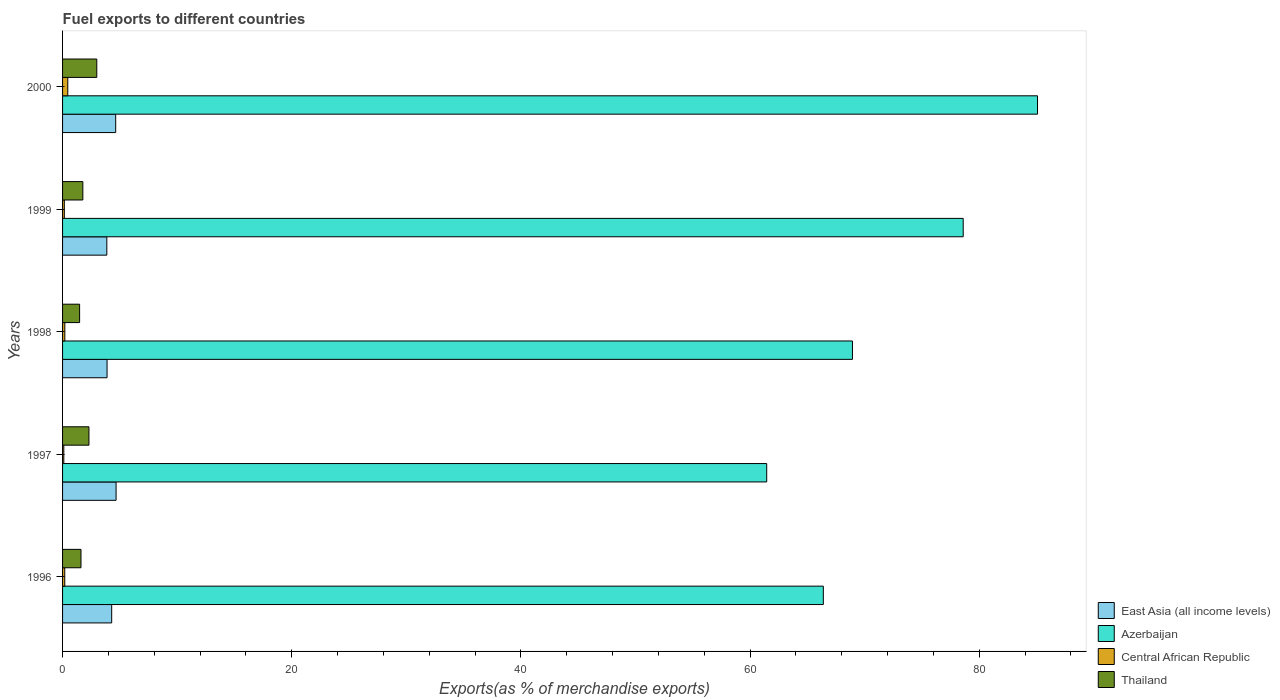Are the number of bars per tick equal to the number of legend labels?
Keep it short and to the point. Yes. How many bars are there on the 4th tick from the top?
Give a very brief answer. 4. How many bars are there on the 4th tick from the bottom?
Your answer should be very brief. 4. In how many cases, is the number of bars for a given year not equal to the number of legend labels?
Provide a short and direct response. 0. What is the percentage of exports to different countries in Azerbaijan in 1996?
Provide a succinct answer. 66.39. Across all years, what is the maximum percentage of exports to different countries in Azerbaijan?
Your answer should be compact. 85.08. Across all years, what is the minimum percentage of exports to different countries in Thailand?
Make the answer very short. 1.49. What is the total percentage of exports to different countries in Central African Republic in the graph?
Offer a very short reply. 1.1. What is the difference between the percentage of exports to different countries in Central African Republic in 1998 and that in 1999?
Provide a short and direct response. 0.04. What is the difference between the percentage of exports to different countries in Central African Republic in 2000 and the percentage of exports to different countries in Thailand in 1997?
Make the answer very short. -1.85. What is the average percentage of exports to different countries in Azerbaijan per year?
Offer a very short reply. 72.09. In the year 1998, what is the difference between the percentage of exports to different countries in Central African Republic and percentage of exports to different countries in Thailand?
Your answer should be compact. -1.29. In how many years, is the percentage of exports to different countries in Azerbaijan greater than 32 %?
Give a very brief answer. 5. What is the ratio of the percentage of exports to different countries in Central African Republic in 1996 to that in 2000?
Provide a succinct answer. 0.42. Is the percentage of exports to different countries in East Asia (all income levels) in 1996 less than that in 1998?
Make the answer very short. No. What is the difference between the highest and the second highest percentage of exports to different countries in Thailand?
Make the answer very short. 0.69. What is the difference between the highest and the lowest percentage of exports to different countries in East Asia (all income levels)?
Provide a short and direct response. 0.81. In how many years, is the percentage of exports to different countries in Thailand greater than the average percentage of exports to different countries in Thailand taken over all years?
Ensure brevity in your answer.  2. What does the 4th bar from the top in 1999 represents?
Make the answer very short. East Asia (all income levels). What does the 1st bar from the bottom in 1999 represents?
Offer a terse response. East Asia (all income levels). Is it the case that in every year, the sum of the percentage of exports to different countries in East Asia (all income levels) and percentage of exports to different countries in Azerbaijan is greater than the percentage of exports to different countries in Thailand?
Offer a terse response. Yes. How many bars are there?
Your response must be concise. 20. How many years are there in the graph?
Give a very brief answer. 5. What is the difference between two consecutive major ticks on the X-axis?
Offer a terse response. 20. Are the values on the major ticks of X-axis written in scientific E-notation?
Make the answer very short. No. Does the graph contain any zero values?
Ensure brevity in your answer.  No. Does the graph contain grids?
Provide a short and direct response. No. How many legend labels are there?
Make the answer very short. 4. What is the title of the graph?
Give a very brief answer. Fuel exports to different countries. What is the label or title of the X-axis?
Offer a very short reply. Exports(as % of merchandise exports). What is the Exports(as % of merchandise exports) in East Asia (all income levels) in 1996?
Give a very brief answer. 4.29. What is the Exports(as % of merchandise exports) of Azerbaijan in 1996?
Offer a terse response. 66.39. What is the Exports(as % of merchandise exports) of Central African Republic in 1996?
Provide a succinct answer. 0.19. What is the Exports(as % of merchandise exports) of Thailand in 1996?
Offer a very short reply. 1.61. What is the Exports(as % of merchandise exports) in East Asia (all income levels) in 1997?
Ensure brevity in your answer.  4.67. What is the Exports(as % of merchandise exports) in Azerbaijan in 1997?
Your response must be concise. 61.45. What is the Exports(as % of merchandise exports) of Central African Republic in 1997?
Offer a very short reply. 0.11. What is the Exports(as % of merchandise exports) in Thailand in 1997?
Your answer should be compact. 2.3. What is the Exports(as % of merchandise exports) of East Asia (all income levels) in 1998?
Your response must be concise. 3.88. What is the Exports(as % of merchandise exports) of Azerbaijan in 1998?
Keep it short and to the point. 68.93. What is the Exports(as % of merchandise exports) in Central African Republic in 1998?
Keep it short and to the point. 0.2. What is the Exports(as % of merchandise exports) in Thailand in 1998?
Your answer should be compact. 1.49. What is the Exports(as % of merchandise exports) in East Asia (all income levels) in 1999?
Provide a succinct answer. 3.86. What is the Exports(as % of merchandise exports) in Azerbaijan in 1999?
Ensure brevity in your answer.  78.6. What is the Exports(as % of merchandise exports) of Central African Republic in 1999?
Make the answer very short. 0.15. What is the Exports(as % of merchandise exports) of Thailand in 1999?
Your answer should be compact. 1.77. What is the Exports(as % of merchandise exports) in East Asia (all income levels) in 2000?
Provide a succinct answer. 4.64. What is the Exports(as % of merchandise exports) of Azerbaijan in 2000?
Keep it short and to the point. 85.08. What is the Exports(as % of merchandise exports) of Central African Republic in 2000?
Offer a terse response. 0.45. What is the Exports(as % of merchandise exports) of Thailand in 2000?
Keep it short and to the point. 2.99. Across all years, what is the maximum Exports(as % of merchandise exports) of East Asia (all income levels)?
Your answer should be compact. 4.67. Across all years, what is the maximum Exports(as % of merchandise exports) in Azerbaijan?
Your answer should be compact. 85.08. Across all years, what is the maximum Exports(as % of merchandise exports) in Central African Republic?
Your answer should be compact. 0.45. Across all years, what is the maximum Exports(as % of merchandise exports) in Thailand?
Ensure brevity in your answer.  2.99. Across all years, what is the minimum Exports(as % of merchandise exports) in East Asia (all income levels)?
Your answer should be compact. 3.86. Across all years, what is the minimum Exports(as % of merchandise exports) of Azerbaijan?
Keep it short and to the point. 61.45. Across all years, what is the minimum Exports(as % of merchandise exports) in Central African Republic?
Your response must be concise. 0.11. Across all years, what is the minimum Exports(as % of merchandise exports) of Thailand?
Your answer should be very brief. 1.49. What is the total Exports(as % of merchandise exports) of East Asia (all income levels) in the graph?
Your response must be concise. 21.34. What is the total Exports(as % of merchandise exports) of Azerbaijan in the graph?
Provide a short and direct response. 360.45. What is the total Exports(as % of merchandise exports) in Central African Republic in the graph?
Your response must be concise. 1.1. What is the total Exports(as % of merchandise exports) of Thailand in the graph?
Provide a short and direct response. 10.15. What is the difference between the Exports(as % of merchandise exports) in East Asia (all income levels) in 1996 and that in 1997?
Offer a terse response. -0.38. What is the difference between the Exports(as % of merchandise exports) of Azerbaijan in 1996 and that in 1997?
Keep it short and to the point. 4.94. What is the difference between the Exports(as % of merchandise exports) in Central African Republic in 1996 and that in 1997?
Your answer should be very brief. 0.08. What is the difference between the Exports(as % of merchandise exports) in Thailand in 1996 and that in 1997?
Ensure brevity in your answer.  -0.69. What is the difference between the Exports(as % of merchandise exports) in East Asia (all income levels) in 1996 and that in 1998?
Ensure brevity in your answer.  0.4. What is the difference between the Exports(as % of merchandise exports) of Azerbaijan in 1996 and that in 1998?
Keep it short and to the point. -2.54. What is the difference between the Exports(as % of merchandise exports) in Central African Republic in 1996 and that in 1998?
Ensure brevity in your answer.  -0.01. What is the difference between the Exports(as % of merchandise exports) in Thailand in 1996 and that in 1998?
Ensure brevity in your answer.  0.12. What is the difference between the Exports(as % of merchandise exports) in East Asia (all income levels) in 1996 and that in 1999?
Offer a very short reply. 0.42. What is the difference between the Exports(as % of merchandise exports) of Azerbaijan in 1996 and that in 1999?
Provide a succinct answer. -12.21. What is the difference between the Exports(as % of merchandise exports) in Central African Republic in 1996 and that in 1999?
Keep it short and to the point. 0.04. What is the difference between the Exports(as % of merchandise exports) in Thailand in 1996 and that in 1999?
Your answer should be very brief. -0.16. What is the difference between the Exports(as % of merchandise exports) of East Asia (all income levels) in 1996 and that in 2000?
Make the answer very short. -0.35. What is the difference between the Exports(as % of merchandise exports) in Azerbaijan in 1996 and that in 2000?
Your answer should be compact. -18.69. What is the difference between the Exports(as % of merchandise exports) of Central African Republic in 1996 and that in 2000?
Ensure brevity in your answer.  -0.26. What is the difference between the Exports(as % of merchandise exports) in Thailand in 1996 and that in 2000?
Ensure brevity in your answer.  -1.38. What is the difference between the Exports(as % of merchandise exports) of East Asia (all income levels) in 1997 and that in 1998?
Make the answer very short. 0.79. What is the difference between the Exports(as % of merchandise exports) of Azerbaijan in 1997 and that in 1998?
Make the answer very short. -7.48. What is the difference between the Exports(as % of merchandise exports) in Central African Republic in 1997 and that in 1998?
Your response must be concise. -0.09. What is the difference between the Exports(as % of merchandise exports) in Thailand in 1997 and that in 1998?
Give a very brief answer. 0.81. What is the difference between the Exports(as % of merchandise exports) in East Asia (all income levels) in 1997 and that in 1999?
Offer a very short reply. 0.81. What is the difference between the Exports(as % of merchandise exports) of Azerbaijan in 1997 and that in 1999?
Your answer should be compact. -17.15. What is the difference between the Exports(as % of merchandise exports) in Central African Republic in 1997 and that in 1999?
Give a very brief answer. -0.05. What is the difference between the Exports(as % of merchandise exports) in Thailand in 1997 and that in 1999?
Offer a very short reply. 0.53. What is the difference between the Exports(as % of merchandise exports) of East Asia (all income levels) in 1997 and that in 2000?
Your answer should be compact. 0.03. What is the difference between the Exports(as % of merchandise exports) in Azerbaijan in 1997 and that in 2000?
Keep it short and to the point. -23.63. What is the difference between the Exports(as % of merchandise exports) in Central African Republic in 1997 and that in 2000?
Provide a short and direct response. -0.35. What is the difference between the Exports(as % of merchandise exports) in Thailand in 1997 and that in 2000?
Make the answer very short. -0.69. What is the difference between the Exports(as % of merchandise exports) in East Asia (all income levels) in 1998 and that in 1999?
Give a very brief answer. 0.02. What is the difference between the Exports(as % of merchandise exports) of Azerbaijan in 1998 and that in 1999?
Provide a succinct answer. -9.66. What is the difference between the Exports(as % of merchandise exports) of Central African Republic in 1998 and that in 1999?
Ensure brevity in your answer.  0.04. What is the difference between the Exports(as % of merchandise exports) in Thailand in 1998 and that in 1999?
Give a very brief answer. -0.28. What is the difference between the Exports(as % of merchandise exports) of East Asia (all income levels) in 1998 and that in 2000?
Your answer should be compact. -0.75. What is the difference between the Exports(as % of merchandise exports) in Azerbaijan in 1998 and that in 2000?
Your response must be concise. -16.15. What is the difference between the Exports(as % of merchandise exports) of Central African Republic in 1998 and that in 2000?
Offer a terse response. -0.26. What is the difference between the Exports(as % of merchandise exports) of Thailand in 1998 and that in 2000?
Ensure brevity in your answer.  -1.5. What is the difference between the Exports(as % of merchandise exports) in East Asia (all income levels) in 1999 and that in 2000?
Ensure brevity in your answer.  -0.77. What is the difference between the Exports(as % of merchandise exports) of Azerbaijan in 1999 and that in 2000?
Ensure brevity in your answer.  -6.48. What is the difference between the Exports(as % of merchandise exports) in Central African Republic in 1999 and that in 2000?
Provide a succinct answer. -0.3. What is the difference between the Exports(as % of merchandise exports) of Thailand in 1999 and that in 2000?
Give a very brief answer. -1.22. What is the difference between the Exports(as % of merchandise exports) in East Asia (all income levels) in 1996 and the Exports(as % of merchandise exports) in Azerbaijan in 1997?
Give a very brief answer. -57.16. What is the difference between the Exports(as % of merchandise exports) of East Asia (all income levels) in 1996 and the Exports(as % of merchandise exports) of Central African Republic in 1997?
Your answer should be compact. 4.18. What is the difference between the Exports(as % of merchandise exports) of East Asia (all income levels) in 1996 and the Exports(as % of merchandise exports) of Thailand in 1997?
Provide a succinct answer. 1.99. What is the difference between the Exports(as % of merchandise exports) in Azerbaijan in 1996 and the Exports(as % of merchandise exports) in Central African Republic in 1997?
Ensure brevity in your answer.  66.28. What is the difference between the Exports(as % of merchandise exports) in Azerbaijan in 1996 and the Exports(as % of merchandise exports) in Thailand in 1997?
Provide a short and direct response. 64.09. What is the difference between the Exports(as % of merchandise exports) in Central African Republic in 1996 and the Exports(as % of merchandise exports) in Thailand in 1997?
Offer a terse response. -2.11. What is the difference between the Exports(as % of merchandise exports) in East Asia (all income levels) in 1996 and the Exports(as % of merchandise exports) in Azerbaijan in 1998?
Offer a terse response. -64.64. What is the difference between the Exports(as % of merchandise exports) in East Asia (all income levels) in 1996 and the Exports(as % of merchandise exports) in Central African Republic in 1998?
Ensure brevity in your answer.  4.09. What is the difference between the Exports(as % of merchandise exports) in East Asia (all income levels) in 1996 and the Exports(as % of merchandise exports) in Thailand in 1998?
Keep it short and to the point. 2.8. What is the difference between the Exports(as % of merchandise exports) in Azerbaijan in 1996 and the Exports(as % of merchandise exports) in Central African Republic in 1998?
Offer a very short reply. 66.19. What is the difference between the Exports(as % of merchandise exports) of Azerbaijan in 1996 and the Exports(as % of merchandise exports) of Thailand in 1998?
Your answer should be compact. 64.9. What is the difference between the Exports(as % of merchandise exports) of Central African Republic in 1996 and the Exports(as % of merchandise exports) of Thailand in 1998?
Offer a very short reply. -1.3. What is the difference between the Exports(as % of merchandise exports) in East Asia (all income levels) in 1996 and the Exports(as % of merchandise exports) in Azerbaijan in 1999?
Offer a terse response. -74.31. What is the difference between the Exports(as % of merchandise exports) of East Asia (all income levels) in 1996 and the Exports(as % of merchandise exports) of Central African Republic in 1999?
Your response must be concise. 4.13. What is the difference between the Exports(as % of merchandise exports) of East Asia (all income levels) in 1996 and the Exports(as % of merchandise exports) of Thailand in 1999?
Offer a very short reply. 2.52. What is the difference between the Exports(as % of merchandise exports) in Azerbaijan in 1996 and the Exports(as % of merchandise exports) in Central African Republic in 1999?
Offer a terse response. 66.24. What is the difference between the Exports(as % of merchandise exports) of Azerbaijan in 1996 and the Exports(as % of merchandise exports) of Thailand in 1999?
Make the answer very short. 64.62. What is the difference between the Exports(as % of merchandise exports) of Central African Republic in 1996 and the Exports(as % of merchandise exports) of Thailand in 1999?
Your answer should be very brief. -1.58. What is the difference between the Exports(as % of merchandise exports) of East Asia (all income levels) in 1996 and the Exports(as % of merchandise exports) of Azerbaijan in 2000?
Offer a terse response. -80.79. What is the difference between the Exports(as % of merchandise exports) of East Asia (all income levels) in 1996 and the Exports(as % of merchandise exports) of Central African Republic in 2000?
Your answer should be compact. 3.83. What is the difference between the Exports(as % of merchandise exports) of East Asia (all income levels) in 1996 and the Exports(as % of merchandise exports) of Thailand in 2000?
Offer a very short reply. 1.3. What is the difference between the Exports(as % of merchandise exports) of Azerbaijan in 1996 and the Exports(as % of merchandise exports) of Central African Republic in 2000?
Keep it short and to the point. 65.94. What is the difference between the Exports(as % of merchandise exports) in Azerbaijan in 1996 and the Exports(as % of merchandise exports) in Thailand in 2000?
Provide a succinct answer. 63.4. What is the difference between the Exports(as % of merchandise exports) in Central African Republic in 1996 and the Exports(as % of merchandise exports) in Thailand in 2000?
Your answer should be very brief. -2.8. What is the difference between the Exports(as % of merchandise exports) in East Asia (all income levels) in 1997 and the Exports(as % of merchandise exports) in Azerbaijan in 1998?
Your answer should be compact. -64.26. What is the difference between the Exports(as % of merchandise exports) of East Asia (all income levels) in 1997 and the Exports(as % of merchandise exports) of Central African Republic in 1998?
Offer a terse response. 4.47. What is the difference between the Exports(as % of merchandise exports) of East Asia (all income levels) in 1997 and the Exports(as % of merchandise exports) of Thailand in 1998?
Offer a very short reply. 3.18. What is the difference between the Exports(as % of merchandise exports) in Azerbaijan in 1997 and the Exports(as % of merchandise exports) in Central African Republic in 1998?
Give a very brief answer. 61.25. What is the difference between the Exports(as % of merchandise exports) of Azerbaijan in 1997 and the Exports(as % of merchandise exports) of Thailand in 1998?
Make the answer very short. 59.96. What is the difference between the Exports(as % of merchandise exports) of Central African Republic in 1997 and the Exports(as % of merchandise exports) of Thailand in 1998?
Your response must be concise. -1.38. What is the difference between the Exports(as % of merchandise exports) of East Asia (all income levels) in 1997 and the Exports(as % of merchandise exports) of Azerbaijan in 1999?
Your answer should be very brief. -73.93. What is the difference between the Exports(as % of merchandise exports) of East Asia (all income levels) in 1997 and the Exports(as % of merchandise exports) of Central African Republic in 1999?
Provide a succinct answer. 4.52. What is the difference between the Exports(as % of merchandise exports) of East Asia (all income levels) in 1997 and the Exports(as % of merchandise exports) of Thailand in 1999?
Provide a succinct answer. 2.9. What is the difference between the Exports(as % of merchandise exports) in Azerbaijan in 1997 and the Exports(as % of merchandise exports) in Central African Republic in 1999?
Give a very brief answer. 61.29. What is the difference between the Exports(as % of merchandise exports) in Azerbaijan in 1997 and the Exports(as % of merchandise exports) in Thailand in 1999?
Give a very brief answer. 59.68. What is the difference between the Exports(as % of merchandise exports) of Central African Republic in 1997 and the Exports(as % of merchandise exports) of Thailand in 1999?
Provide a succinct answer. -1.66. What is the difference between the Exports(as % of merchandise exports) in East Asia (all income levels) in 1997 and the Exports(as % of merchandise exports) in Azerbaijan in 2000?
Provide a short and direct response. -80.41. What is the difference between the Exports(as % of merchandise exports) in East Asia (all income levels) in 1997 and the Exports(as % of merchandise exports) in Central African Republic in 2000?
Make the answer very short. 4.21. What is the difference between the Exports(as % of merchandise exports) of East Asia (all income levels) in 1997 and the Exports(as % of merchandise exports) of Thailand in 2000?
Your answer should be very brief. 1.68. What is the difference between the Exports(as % of merchandise exports) in Azerbaijan in 1997 and the Exports(as % of merchandise exports) in Central African Republic in 2000?
Provide a short and direct response. 60.99. What is the difference between the Exports(as % of merchandise exports) of Azerbaijan in 1997 and the Exports(as % of merchandise exports) of Thailand in 2000?
Keep it short and to the point. 58.46. What is the difference between the Exports(as % of merchandise exports) of Central African Republic in 1997 and the Exports(as % of merchandise exports) of Thailand in 2000?
Keep it short and to the point. -2.88. What is the difference between the Exports(as % of merchandise exports) of East Asia (all income levels) in 1998 and the Exports(as % of merchandise exports) of Azerbaijan in 1999?
Give a very brief answer. -74.71. What is the difference between the Exports(as % of merchandise exports) in East Asia (all income levels) in 1998 and the Exports(as % of merchandise exports) in Central African Republic in 1999?
Your answer should be very brief. 3.73. What is the difference between the Exports(as % of merchandise exports) in East Asia (all income levels) in 1998 and the Exports(as % of merchandise exports) in Thailand in 1999?
Your answer should be compact. 2.11. What is the difference between the Exports(as % of merchandise exports) of Azerbaijan in 1998 and the Exports(as % of merchandise exports) of Central African Republic in 1999?
Your response must be concise. 68.78. What is the difference between the Exports(as % of merchandise exports) of Azerbaijan in 1998 and the Exports(as % of merchandise exports) of Thailand in 1999?
Make the answer very short. 67.16. What is the difference between the Exports(as % of merchandise exports) in Central African Republic in 1998 and the Exports(as % of merchandise exports) in Thailand in 1999?
Provide a succinct answer. -1.57. What is the difference between the Exports(as % of merchandise exports) of East Asia (all income levels) in 1998 and the Exports(as % of merchandise exports) of Azerbaijan in 2000?
Make the answer very short. -81.2. What is the difference between the Exports(as % of merchandise exports) of East Asia (all income levels) in 1998 and the Exports(as % of merchandise exports) of Central African Republic in 2000?
Give a very brief answer. 3.43. What is the difference between the Exports(as % of merchandise exports) of East Asia (all income levels) in 1998 and the Exports(as % of merchandise exports) of Thailand in 2000?
Your answer should be very brief. 0.9. What is the difference between the Exports(as % of merchandise exports) of Azerbaijan in 1998 and the Exports(as % of merchandise exports) of Central African Republic in 2000?
Provide a short and direct response. 68.48. What is the difference between the Exports(as % of merchandise exports) in Azerbaijan in 1998 and the Exports(as % of merchandise exports) in Thailand in 2000?
Make the answer very short. 65.94. What is the difference between the Exports(as % of merchandise exports) in Central African Republic in 1998 and the Exports(as % of merchandise exports) in Thailand in 2000?
Offer a terse response. -2.79. What is the difference between the Exports(as % of merchandise exports) of East Asia (all income levels) in 1999 and the Exports(as % of merchandise exports) of Azerbaijan in 2000?
Offer a terse response. -81.22. What is the difference between the Exports(as % of merchandise exports) in East Asia (all income levels) in 1999 and the Exports(as % of merchandise exports) in Central African Republic in 2000?
Offer a very short reply. 3.41. What is the difference between the Exports(as % of merchandise exports) in East Asia (all income levels) in 1999 and the Exports(as % of merchandise exports) in Thailand in 2000?
Keep it short and to the point. 0.88. What is the difference between the Exports(as % of merchandise exports) in Azerbaijan in 1999 and the Exports(as % of merchandise exports) in Central African Republic in 2000?
Ensure brevity in your answer.  78.14. What is the difference between the Exports(as % of merchandise exports) in Azerbaijan in 1999 and the Exports(as % of merchandise exports) in Thailand in 2000?
Offer a very short reply. 75.61. What is the difference between the Exports(as % of merchandise exports) of Central African Republic in 1999 and the Exports(as % of merchandise exports) of Thailand in 2000?
Your response must be concise. -2.83. What is the average Exports(as % of merchandise exports) of East Asia (all income levels) per year?
Ensure brevity in your answer.  4.27. What is the average Exports(as % of merchandise exports) in Azerbaijan per year?
Ensure brevity in your answer.  72.09. What is the average Exports(as % of merchandise exports) in Central African Republic per year?
Provide a short and direct response. 0.22. What is the average Exports(as % of merchandise exports) in Thailand per year?
Offer a terse response. 2.03. In the year 1996, what is the difference between the Exports(as % of merchandise exports) in East Asia (all income levels) and Exports(as % of merchandise exports) in Azerbaijan?
Your response must be concise. -62.1. In the year 1996, what is the difference between the Exports(as % of merchandise exports) of East Asia (all income levels) and Exports(as % of merchandise exports) of Central African Republic?
Keep it short and to the point. 4.1. In the year 1996, what is the difference between the Exports(as % of merchandise exports) of East Asia (all income levels) and Exports(as % of merchandise exports) of Thailand?
Offer a very short reply. 2.68. In the year 1996, what is the difference between the Exports(as % of merchandise exports) in Azerbaijan and Exports(as % of merchandise exports) in Central African Republic?
Your answer should be compact. 66.2. In the year 1996, what is the difference between the Exports(as % of merchandise exports) of Azerbaijan and Exports(as % of merchandise exports) of Thailand?
Give a very brief answer. 64.78. In the year 1996, what is the difference between the Exports(as % of merchandise exports) of Central African Republic and Exports(as % of merchandise exports) of Thailand?
Offer a very short reply. -1.42. In the year 1997, what is the difference between the Exports(as % of merchandise exports) in East Asia (all income levels) and Exports(as % of merchandise exports) in Azerbaijan?
Give a very brief answer. -56.78. In the year 1997, what is the difference between the Exports(as % of merchandise exports) of East Asia (all income levels) and Exports(as % of merchandise exports) of Central African Republic?
Keep it short and to the point. 4.56. In the year 1997, what is the difference between the Exports(as % of merchandise exports) of East Asia (all income levels) and Exports(as % of merchandise exports) of Thailand?
Your response must be concise. 2.37. In the year 1997, what is the difference between the Exports(as % of merchandise exports) in Azerbaijan and Exports(as % of merchandise exports) in Central African Republic?
Keep it short and to the point. 61.34. In the year 1997, what is the difference between the Exports(as % of merchandise exports) of Azerbaijan and Exports(as % of merchandise exports) of Thailand?
Your response must be concise. 59.15. In the year 1997, what is the difference between the Exports(as % of merchandise exports) of Central African Republic and Exports(as % of merchandise exports) of Thailand?
Provide a short and direct response. -2.19. In the year 1998, what is the difference between the Exports(as % of merchandise exports) in East Asia (all income levels) and Exports(as % of merchandise exports) in Azerbaijan?
Make the answer very short. -65.05. In the year 1998, what is the difference between the Exports(as % of merchandise exports) in East Asia (all income levels) and Exports(as % of merchandise exports) in Central African Republic?
Offer a very short reply. 3.69. In the year 1998, what is the difference between the Exports(as % of merchandise exports) in East Asia (all income levels) and Exports(as % of merchandise exports) in Thailand?
Your answer should be compact. 2.4. In the year 1998, what is the difference between the Exports(as % of merchandise exports) of Azerbaijan and Exports(as % of merchandise exports) of Central African Republic?
Keep it short and to the point. 68.73. In the year 1998, what is the difference between the Exports(as % of merchandise exports) in Azerbaijan and Exports(as % of merchandise exports) in Thailand?
Make the answer very short. 67.44. In the year 1998, what is the difference between the Exports(as % of merchandise exports) of Central African Republic and Exports(as % of merchandise exports) of Thailand?
Ensure brevity in your answer.  -1.29. In the year 1999, what is the difference between the Exports(as % of merchandise exports) in East Asia (all income levels) and Exports(as % of merchandise exports) in Azerbaijan?
Make the answer very short. -74.73. In the year 1999, what is the difference between the Exports(as % of merchandise exports) in East Asia (all income levels) and Exports(as % of merchandise exports) in Central African Republic?
Keep it short and to the point. 3.71. In the year 1999, what is the difference between the Exports(as % of merchandise exports) in East Asia (all income levels) and Exports(as % of merchandise exports) in Thailand?
Ensure brevity in your answer.  2.09. In the year 1999, what is the difference between the Exports(as % of merchandise exports) of Azerbaijan and Exports(as % of merchandise exports) of Central African Republic?
Offer a very short reply. 78.44. In the year 1999, what is the difference between the Exports(as % of merchandise exports) in Azerbaijan and Exports(as % of merchandise exports) in Thailand?
Offer a very short reply. 76.83. In the year 1999, what is the difference between the Exports(as % of merchandise exports) in Central African Republic and Exports(as % of merchandise exports) in Thailand?
Offer a terse response. -1.62. In the year 2000, what is the difference between the Exports(as % of merchandise exports) in East Asia (all income levels) and Exports(as % of merchandise exports) in Azerbaijan?
Keep it short and to the point. -80.45. In the year 2000, what is the difference between the Exports(as % of merchandise exports) of East Asia (all income levels) and Exports(as % of merchandise exports) of Central African Republic?
Keep it short and to the point. 4.18. In the year 2000, what is the difference between the Exports(as % of merchandise exports) in East Asia (all income levels) and Exports(as % of merchandise exports) in Thailand?
Your response must be concise. 1.65. In the year 2000, what is the difference between the Exports(as % of merchandise exports) in Azerbaijan and Exports(as % of merchandise exports) in Central African Republic?
Provide a succinct answer. 84.63. In the year 2000, what is the difference between the Exports(as % of merchandise exports) of Azerbaijan and Exports(as % of merchandise exports) of Thailand?
Give a very brief answer. 82.09. In the year 2000, what is the difference between the Exports(as % of merchandise exports) in Central African Republic and Exports(as % of merchandise exports) in Thailand?
Your answer should be very brief. -2.53. What is the ratio of the Exports(as % of merchandise exports) in East Asia (all income levels) in 1996 to that in 1997?
Ensure brevity in your answer.  0.92. What is the ratio of the Exports(as % of merchandise exports) of Azerbaijan in 1996 to that in 1997?
Your answer should be compact. 1.08. What is the ratio of the Exports(as % of merchandise exports) in Central African Republic in 1996 to that in 1997?
Provide a succinct answer. 1.76. What is the ratio of the Exports(as % of merchandise exports) of Thailand in 1996 to that in 1997?
Ensure brevity in your answer.  0.7. What is the ratio of the Exports(as % of merchandise exports) in East Asia (all income levels) in 1996 to that in 1998?
Your response must be concise. 1.1. What is the ratio of the Exports(as % of merchandise exports) of Azerbaijan in 1996 to that in 1998?
Make the answer very short. 0.96. What is the ratio of the Exports(as % of merchandise exports) in Central African Republic in 1996 to that in 1998?
Provide a succinct answer. 0.97. What is the ratio of the Exports(as % of merchandise exports) in Thailand in 1996 to that in 1998?
Provide a short and direct response. 1.08. What is the ratio of the Exports(as % of merchandise exports) of East Asia (all income levels) in 1996 to that in 1999?
Provide a short and direct response. 1.11. What is the ratio of the Exports(as % of merchandise exports) in Azerbaijan in 1996 to that in 1999?
Your answer should be very brief. 0.84. What is the ratio of the Exports(as % of merchandise exports) of Central African Republic in 1996 to that in 1999?
Offer a terse response. 1.24. What is the ratio of the Exports(as % of merchandise exports) in Thailand in 1996 to that in 1999?
Provide a short and direct response. 0.91. What is the ratio of the Exports(as % of merchandise exports) in East Asia (all income levels) in 1996 to that in 2000?
Provide a succinct answer. 0.92. What is the ratio of the Exports(as % of merchandise exports) of Azerbaijan in 1996 to that in 2000?
Give a very brief answer. 0.78. What is the ratio of the Exports(as % of merchandise exports) of Central African Republic in 1996 to that in 2000?
Your answer should be compact. 0.42. What is the ratio of the Exports(as % of merchandise exports) in Thailand in 1996 to that in 2000?
Offer a terse response. 0.54. What is the ratio of the Exports(as % of merchandise exports) in East Asia (all income levels) in 1997 to that in 1998?
Provide a short and direct response. 1.2. What is the ratio of the Exports(as % of merchandise exports) in Azerbaijan in 1997 to that in 1998?
Your answer should be very brief. 0.89. What is the ratio of the Exports(as % of merchandise exports) in Central African Republic in 1997 to that in 1998?
Make the answer very short. 0.55. What is the ratio of the Exports(as % of merchandise exports) in Thailand in 1997 to that in 1998?
Provide a succinct answer. 1.55. What is the ratio of the Exports(as % of merchandise exports) of East Asia (all income levels) in 1997 to that in 1999?
Your answer should be very brief. 1.21. What is the ratio of the Exports(as % of merchandise exports) in Azerbaijan in 1997 to that in 1999?
Give a very brief answer. 0.78. What is the ratio of the Exports(as % of merchandise exports) in Central African Republic in 1997 to that in 1999?
Keep it short and to the point. 0.7. What is the ratio of the Exports(as % of merchandise exports) in Thailand in 1997 to that in 1999?
Keep it short and to the point. 1.3. What is the ratio of the Exports(as % of merchandise exports) in East Asia (all income levels) in 1997 to that in 2000?
Your answer should be very brief. 1.01. What is the ratio of the Exports(as % of merchandise exports) of Azerbaijan in 1997 to that in 2000?
Offer a terse response. 0.72. What is the ratio of the Exports(as % of merchandise exports) of Central African Republic in 1997 to that in 2000?
Keep it short and to the point. 0.24. What is the ratio of the Exports(as % of merchandise exports) of Thailand in 1997 to that in 2000?
Your response must be concise. 0.77. What is the ratio of the Exports(as % of merchandise exports) of Azerbaijan in 1998 to that in 1999?
Your response must be concise. 0.88. What is the ratio of the Exports(as % of merchandise exports) in Central African Republic in 1998 to that in 1999?
Offer a terse response. 1.28. What is the ratio of the Exports(as % of merchandise exports) of Thailand in 1998 to that in 1999?
Make the answer very short. 0.84. What is the ratio of the Exports(as % of merchandise exports) in East Asia (all income levels) in 1998 to that in 2000?
Give a very brief answer. 0.84. What is the ratio of the Exports(as % of merchandise exports) of Azerbaijan in 1998 to that in 2000?
Ensure brevity in your answer.  0.81. What is the ratio of the Exports(as % of merchandise exports) of Central African Republic in 1998 to that in 2000?
Provide a succinct answer. 0.43. What is the ratio of the Exports(as % of merchandise exports) in Thailand in 1998 to that in 2000?
Make the answer very short. 0.5. What is the ratio of the Exports(as % of merchandise exports) of Azerbaijan in 1999 to that in 2000?
Give a very brief answer. 0.92. What is the ratio of the Exports(as % of merchandise exports) in Central African Republic in 1999 to that in 2000?
Keep it short and to the point. 0.34. What is the ratio of the Exports(as % of merchandise exports) of Thailand in 1999 to that in 2000?
Offer a terse response. 0.59. What is the difference between the highest and the second highest Exports(as % of merchandise exports) in East Asia (all income levels)?
Keep it short and to the point. 0.03. What is the difference between the highest and the second highest Exports(as % of merchandise exports) of Azerbaijan?
Keep it short and to the point. 6.48. What is the difference between the highest and the second highest Exports(as % of merchandise exports) in Central African Republic?
Provide a succinct answer. 0.26. What is the difference between the highest and the second highest Exports(as % of merchandise exports) in Thailand?
Give a very brief answer. 0.69. What is the difference between the highest and the lowest Exports(as % of merchandise exports) of East Asia (all income levels)?
Offer a terse response. 0.81. What is the difference between the highest and the lowest Exports(as % of merchandise exports) of Azerbaijan?
Give a very brief answer. 23.63. What is the difference between the highest and the lowest Exports(as % of merchandise exports) in Central African Republic?
Keep it short and to the point. 0.35. What is the difference between the highest and the lowest Exports(as % of merchandise exports) in Thailand?
Keep it short and to the point. 1.5. 